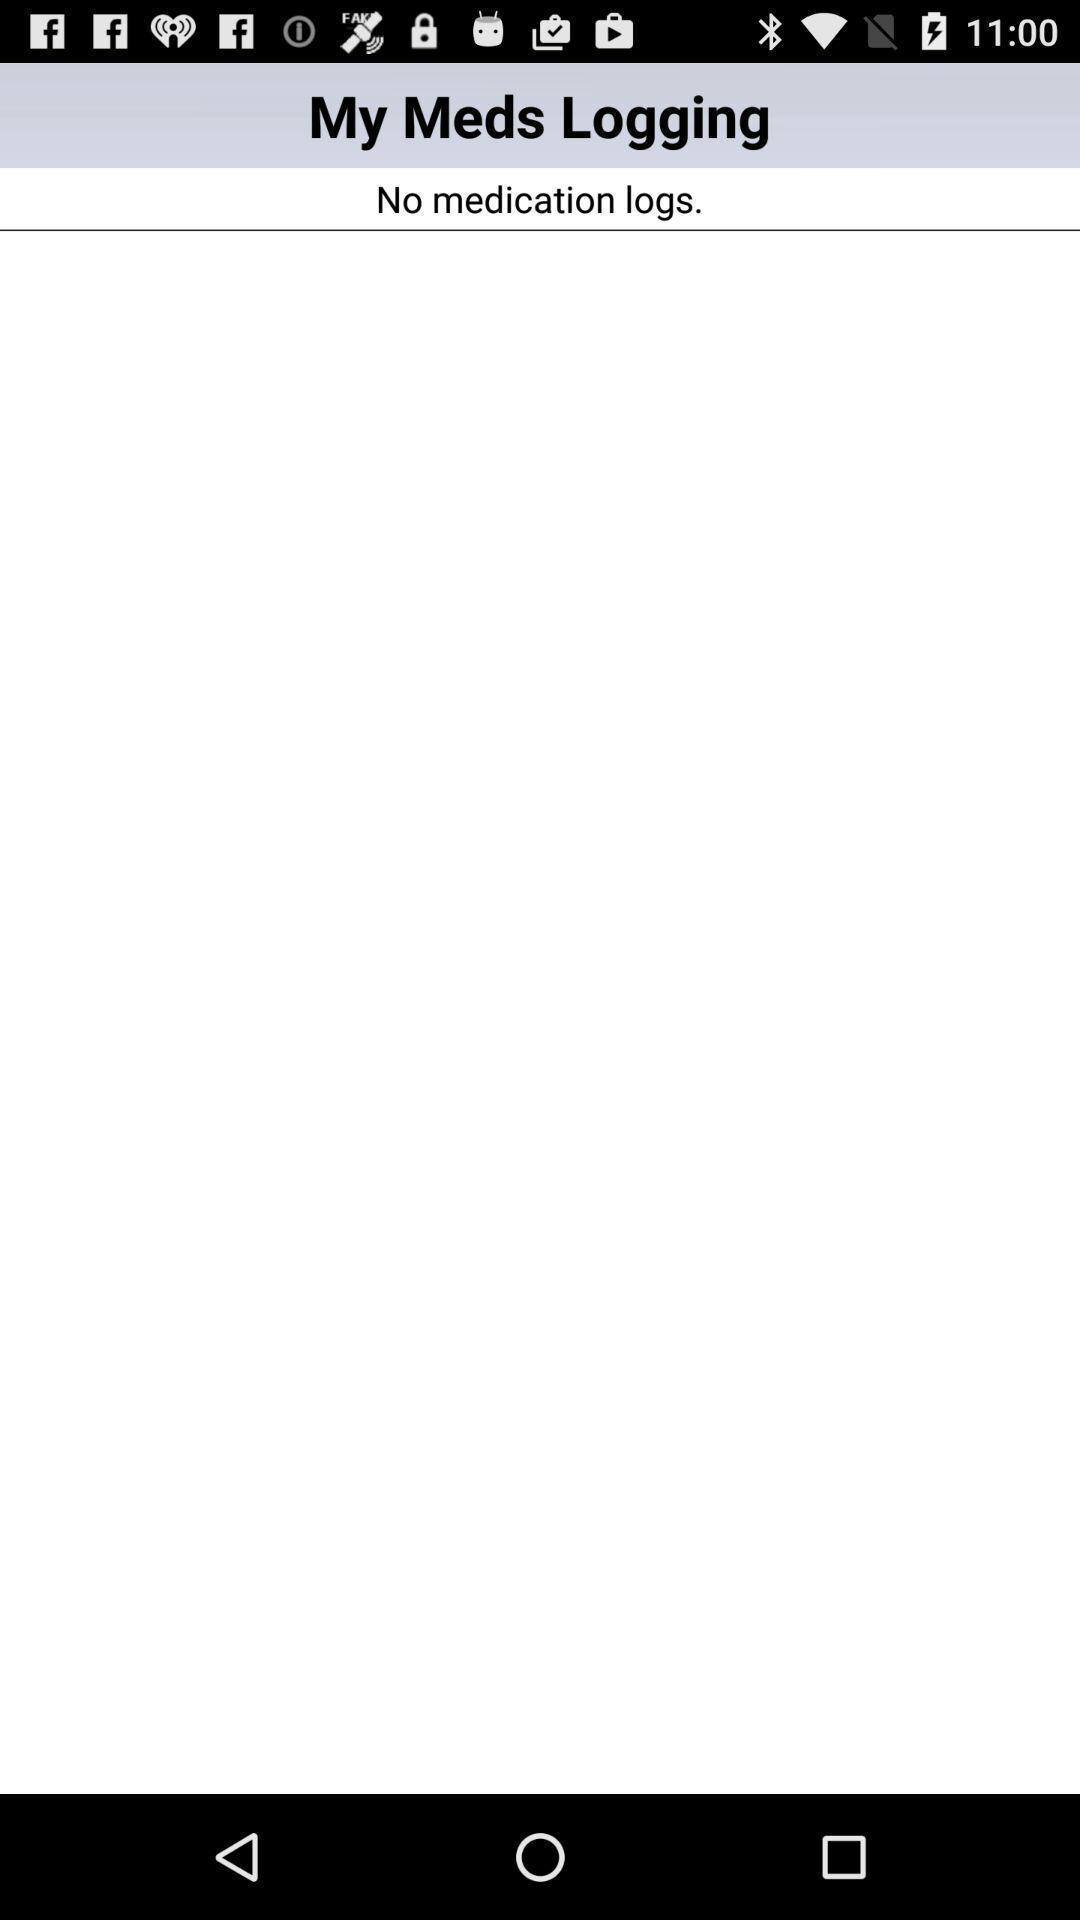Tell me what you see in this picture. Screen displaying the logging activity page which is empty. 